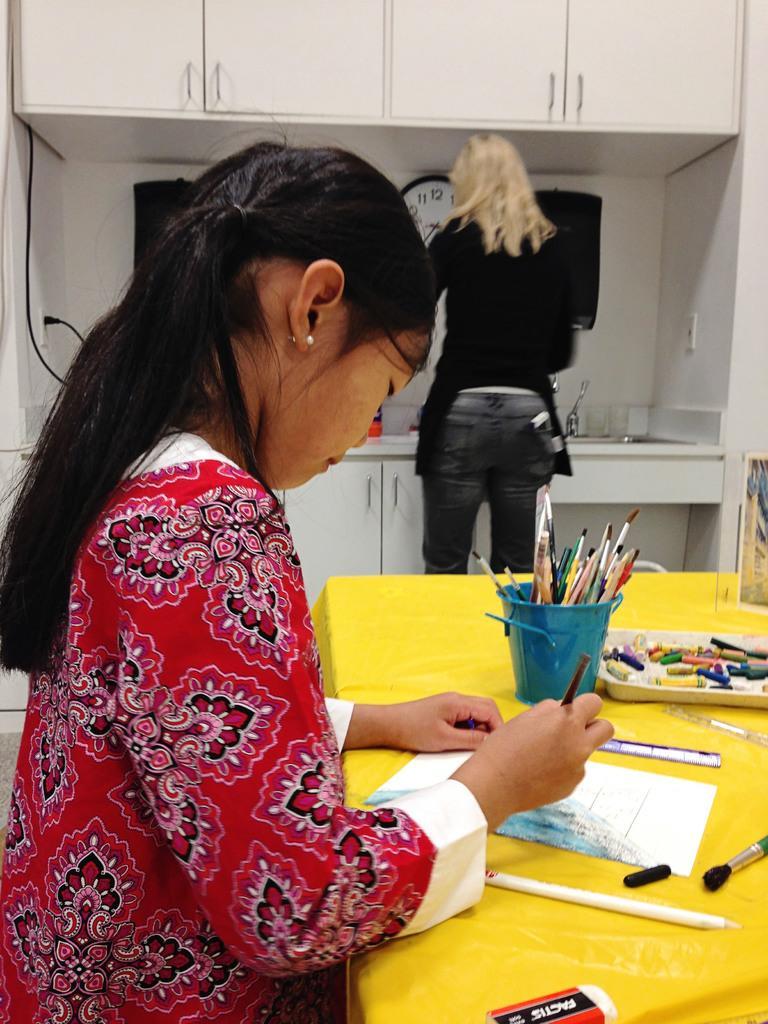Describe this image in one or two sentences. In this image I can see a woman wearing red, white and black colored dress is sitting in front of a yellow colored table and on the table I can see few pens, few papers, an eraser, a tray, a box and few other objects. In the background I can see the counter top , a sink, a clock, the wall, a wire and a woman wearing black color dress is stunning. 